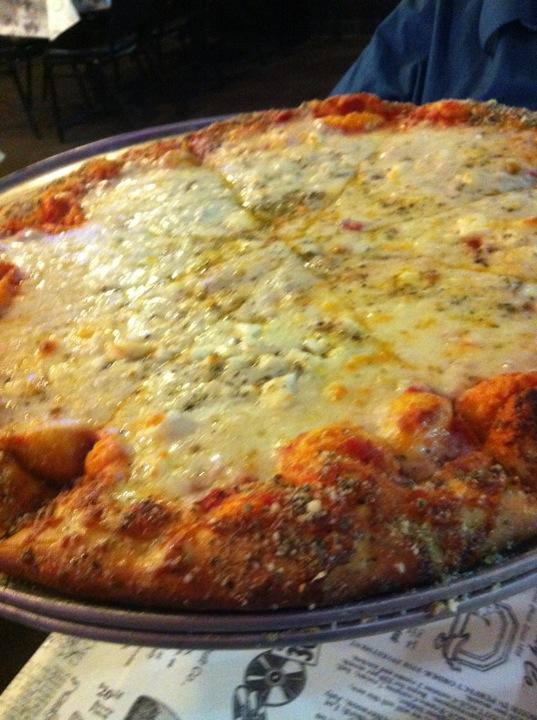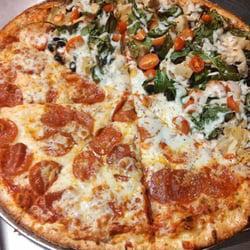The first image is the image on the left, the second image is the image on the right. Analyze the images presented: Is the assertion "In at least one image there is a single slice of pizza on a sliver pizza tray." valid? Answer yes or no. No. The first image is the image on the left, the second image is the image on the right. Given the left and right images, does the statement "The right image shows one round pizza with no slices missingon a round silver tray, and the left image shows at least part of a pizza smothered in white cheese on a round silver tray." hold true? Answer yes or no. Yes. 